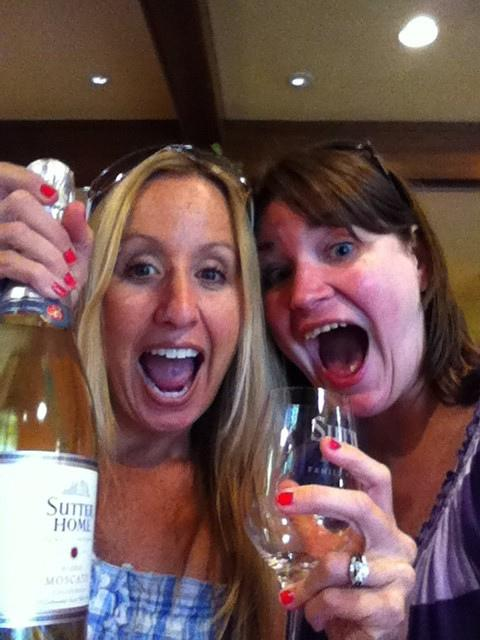What emotion are the woman exhibiting? Please explain your reasoning. joyful. They are happy and having a fun time. 